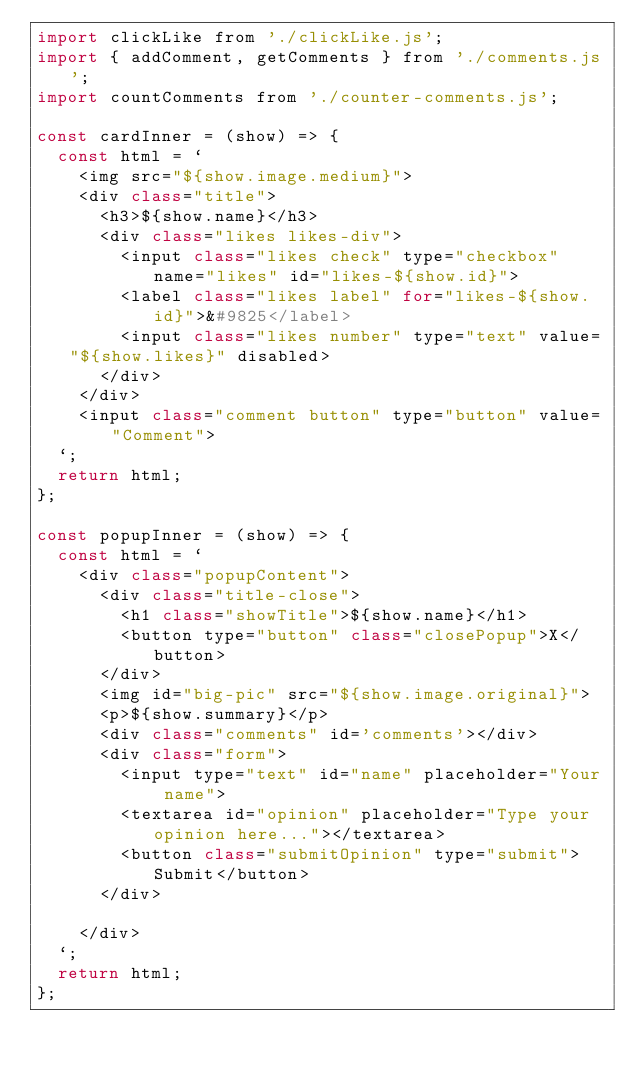<code> <loc_0><loc_0><loc_500><loc_500><_JavaScript_>import clickLike from './clickLike.js';
import { addComment, getComments } from './comments.js';
import countComments from './counter-comments.js';

const cardInner = (show) => {
  const html = `
    <img src="${show.image.medium}">
    <div class="title">
      <h3>${show.name}</h3>
      <div class="likes likes-div">
        <input class="likes check" type="checkbox" name="likes" id="likes-${show.id}">
        <label class="likes label" for="likes-${show.id}">&#9825</label>
        <input class="likes number" type="text" value="${show.likes}" disabled>
      </div>
    </div>
    <input class="comment button" type="button" value="Comment">
  `;
  return html;
};

const popupInner = (show) => {
  const html = `
    <div class="popupContent">
      <div class="title-close">
        <h1 class="showTitle">${show.name}</h1>
        <button type="button" class="closePopup">X</button>
      </div>
      <img id="big-pic" src="${show.image.original}">
      <p>${show.summary}</p>
      <div class="comments" id='comments'></div>
      <div class="form">
        <input type="text" id="name" placeholder="Your name">
        <textarea id="opinion" placeholder="Type your opinion here..."></textarea>
        <button class="submitOpinion" type="submit">Submit</button>
      </div>
      
    </div>
  `;
  return html;
};
</code> 